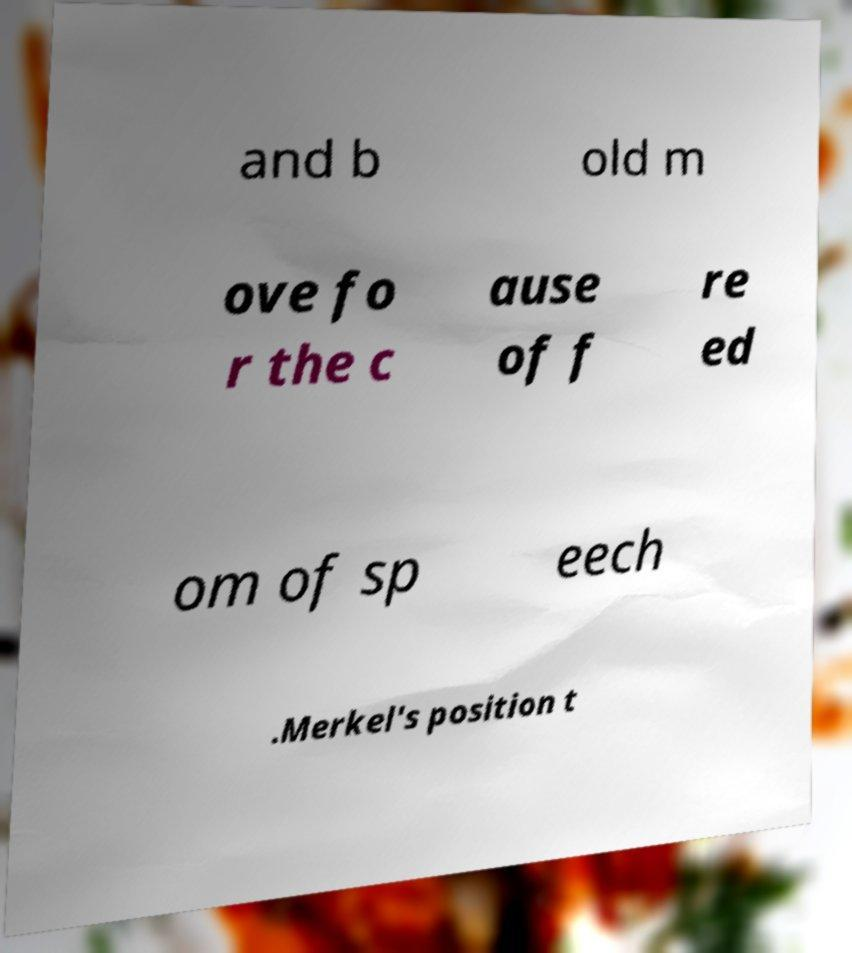What do you think the context of this message might be? The image presents an incomplete and fragmented piece of text, which suggests that it could form part of a larger statement or document related to freedom of speech, given the partial phrases visible. Considering the mention of 'Merkel,' it may be related to political discourse or policy, but without the full text, any definitive context is speculative. 